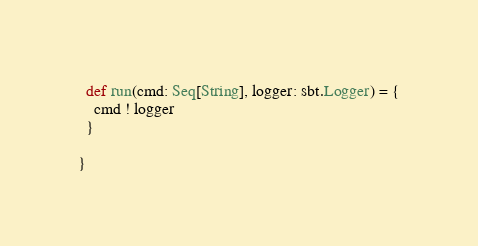Convert code to text. <code><loc_0><loc_0><loc_500><loc_500><_Scala_>  def run(cmd: Seq[String], logger: sbt.Logger) = {
    cmd ! logger
  }

}</code> 